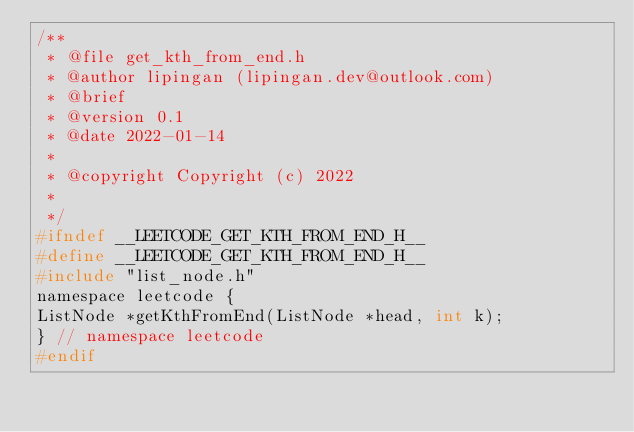Convert code to text. <code><loc_0><loc_0><loc_500><loc_500><_C_>/**
 * @file get_kth_from_end.h
 * @author lipingan (lipingan.dev@outlook.com)
 * @brief
 * @version 0.1
 * @date 2022-01-14
 *
 * @copyright Copyright (c) 2022
 *
 */
#ifndef __LEETCODE_GET_KTH_FROM_END_H__
#define __LEETCODE_GET_KTH_FROM_END_H__
#include "list_node.h"
namespace leetcode {
ListNode *getKthFromEnd(ListNode *head, int k);
} // namespace leetcode
#endif</code> 